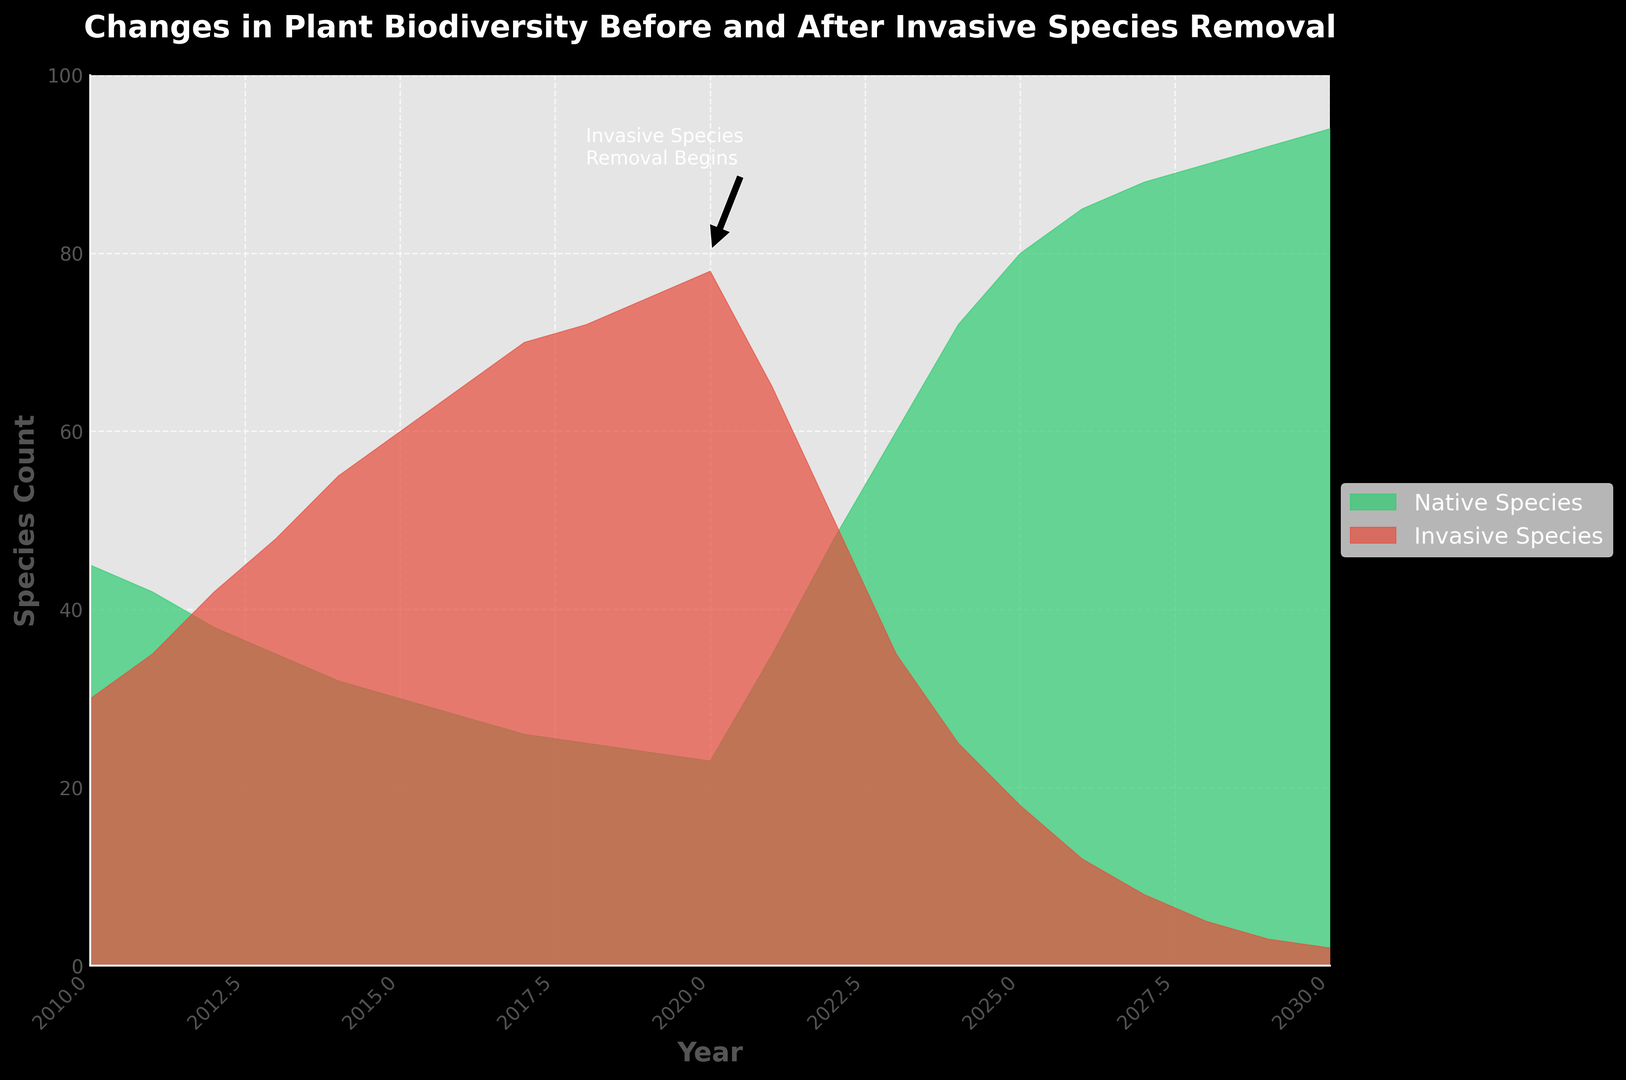What year did the invasive species removal begin? The annotation on the chart indicates that the removal began in 2020.
Answer: 2020 How do the counts of native species compare between the years 2020 and 2021? In 2020, the count of native species is around 23. In 2021, the count increases significantly to about 35.
Answer: Native species increased from 23 to 35 What is the difference in the count of native species between 2015 and 2025? In 2015, the native species count is 30, whereas in 2025, it is 80. The difference is calculated as 80 - 30 = 50.
Answer: 50 What is the combined count of native and invasive species in the year 2023? In 2023, the native species count is 60 and the invasive species count is 35, summing to 60 + 35 = 95.
Answer: 95 Between which two consecutive years did the native species count show the highest increase? The largest increase in native species count occurred between 2021 and 2022, where it increased from 35 to 48, an increase of 13.
Answer: 2021 and 2022 Which year shows the highest count of invasive species and what is that count? The peak of the invasive species count is in the year 2020, where the count is 78.
Answer: 2020, 78 By how much did the invasive species count decrease from 2020 to 2025? In 2020, the count is 78 and in 2025 it is 18. The decrease is calculated as 78 - 18 = 60.
Answer: 60 How does the height of the area representing native species in 2018 compare visually to 2010? In 2010, the height is significantly higher (45) compared to 2018 (25), indicating a decrease in the count of native species.
Answer: Decreased from 45 to 25 What trend can be observed about native species count after the removal of invasive species? Starting from 2020, there is a noticeable increase in the count of native species each subsequent year, indicating recovery.
Answer: Increasing trend What is the visual color representation of native and invasive species in the plot? Native species are represented by a green area, while invasive species are represented by a red area.
Answer: Green and Red 